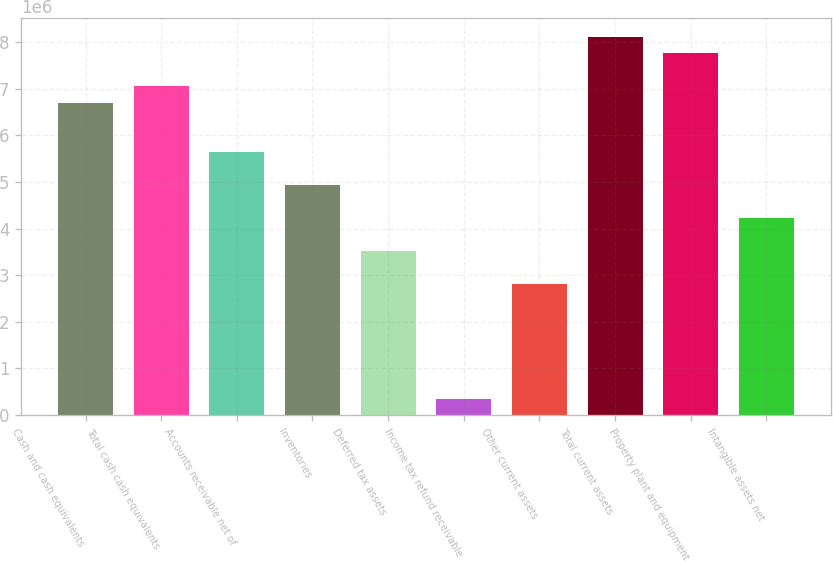Convert chart. <chart><loc_0><loc_0><loc_500><loc_500><bar_chart><fcel>Cash and cash equivalents<fcel>Total cash cash equivalents<fcel>Accounts receivable net of<fcel>Inventories<fcel>Deferred tax assets<fcel>Income tax refund receivable<fcel>Other current assets<fcel>Total current assets<fcel>Property plant and equipment<fcel>Intangible assets net<nl><fcel>6.70245e+06<fcel>7.05519e+06<fcel>5.64421e+06<fcel>4.93872e+06<fcel>3.52774e+06<fcel>353041<fcel>2.82225e+06<fcel>8.11342e+06<fcel>7.76068e+06<fcel>4.23323e+06<nl></chart> 